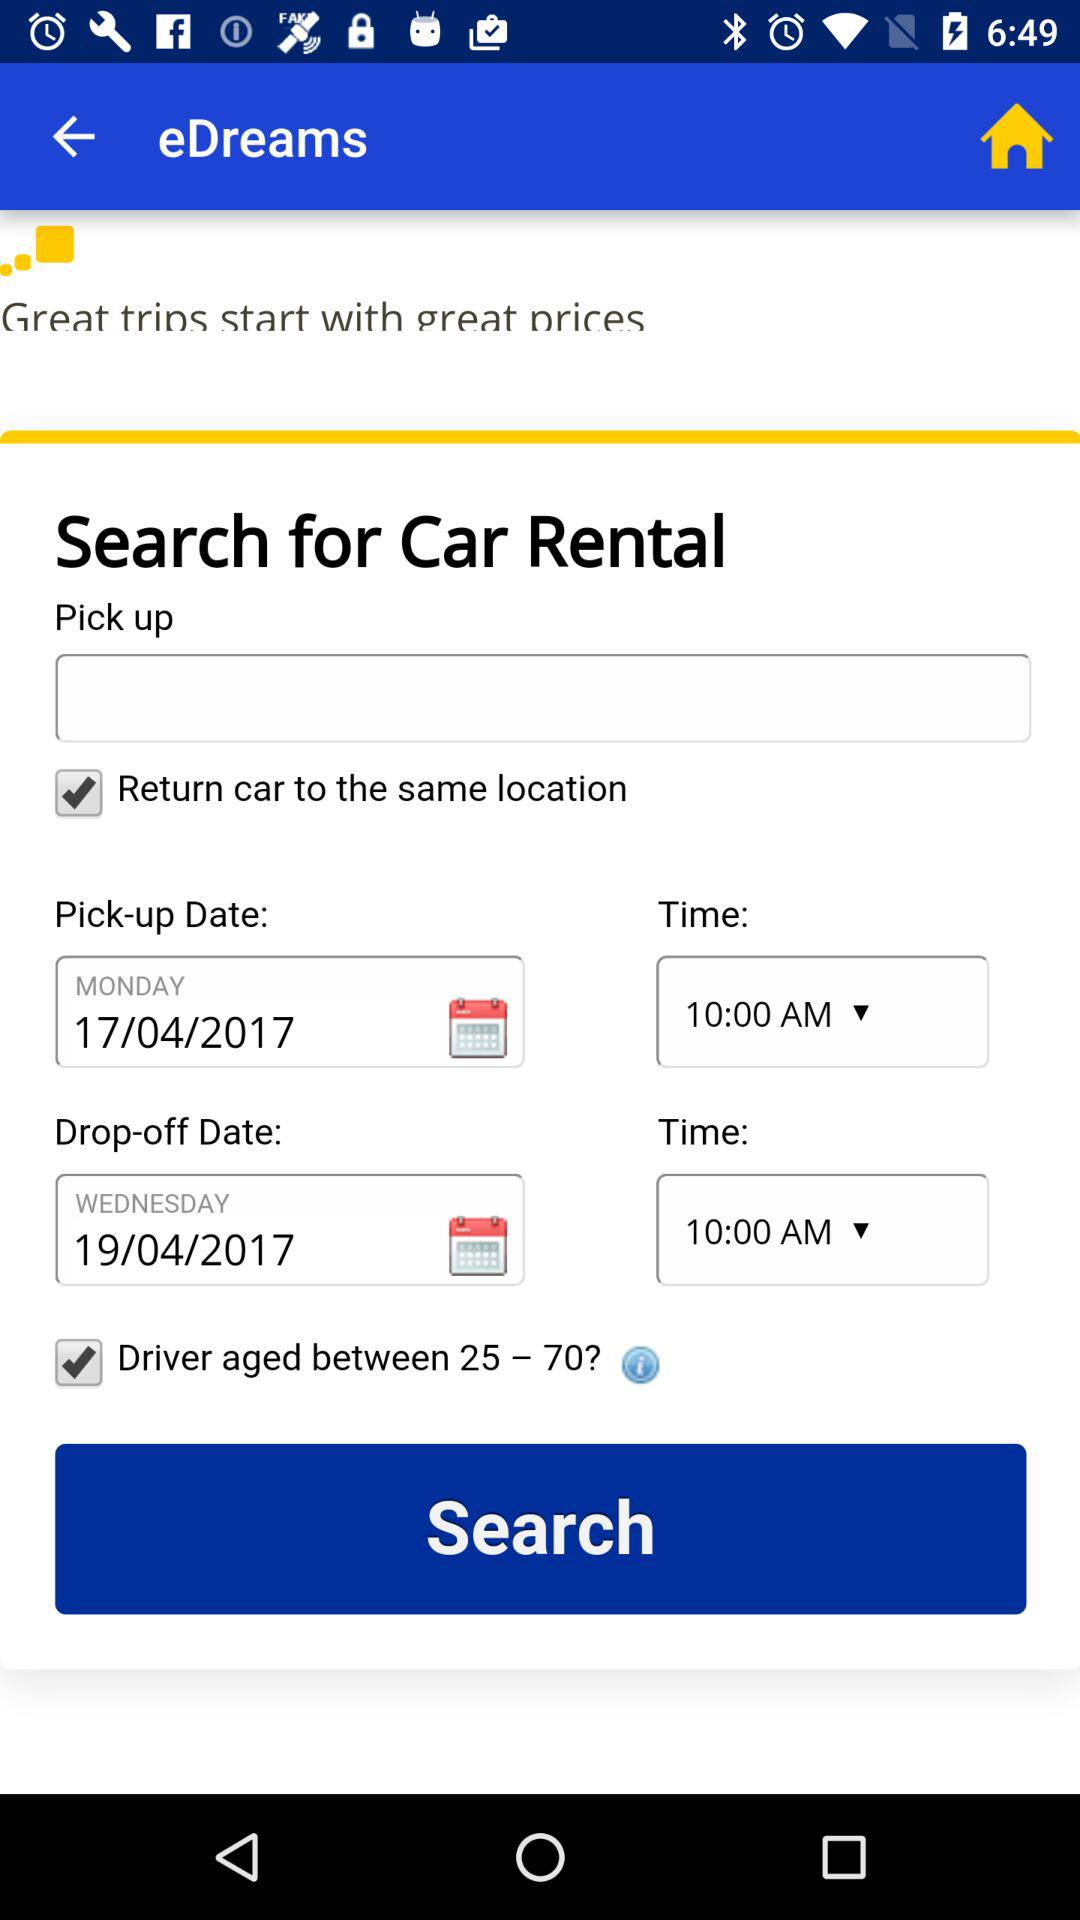What is the drop-off date? The drop-off date is Wednesday, April 19, 2017. 